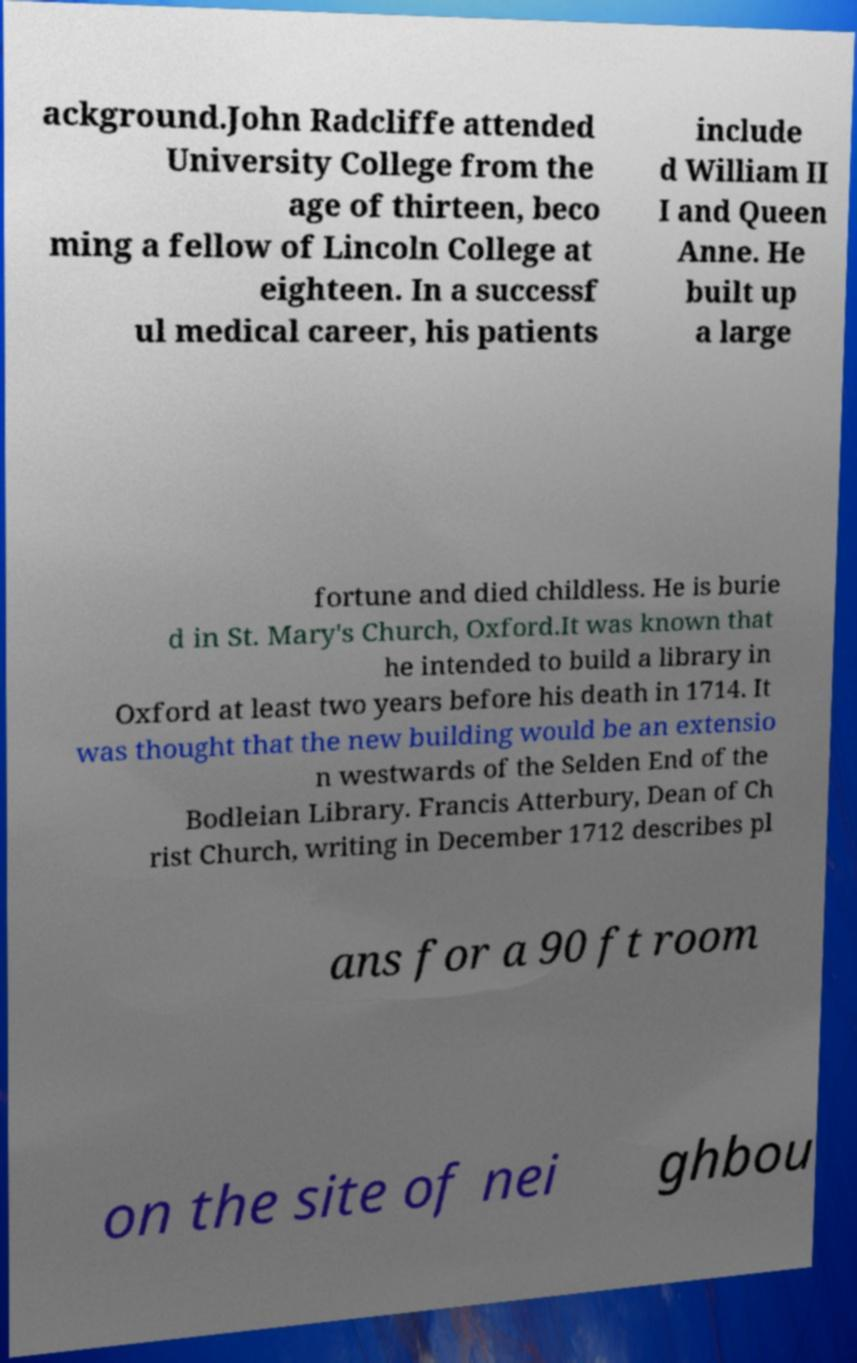Please read and relay the text visible in this image. What does it say? ackground.John Radcliffe attended University College from the age of thirteen, beco ming a fellow of Lincoln College at eighteen. In a successf ul medical career, his patients include d William II I and Queen Anne. He built up a large fortune and died childless. He is burie d in St. Mary's Church, Oxford.It was known that he intended to build a library in Oxford at least two years before his death in 1714. It was thought that the new building would be an extensio n westwards of the Selden End of the Bodleian Library. Francis Atterbury, Dean of Ch rist Church, writing in December 1712 describes pl ans for a 90 ft room on the site of nei ghbou 